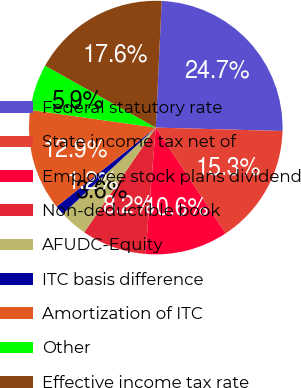Convert chart to OTSL. <chart><loc_0><loc_0><loc_500><loc_500><pie_chart><fcel>Federal statutory rate<fcel>State income tax net of<fcel>Employee stock plans dividend<fcel>Non-deductible book<fcel>AFUDC-Equity<fcel>ITC basis difference<fcel>Amortization of ITC<fcel>Other<fcel>Effective income tax rate<nl><fcel>24.68%<fcel>15.28%<fcel>10.59%<fcel>8.24%<fcel>3.55%<fcel>1.2%<fcel>12.94%<fcel>5.89%<fcel>17.63%<nl></chart> 